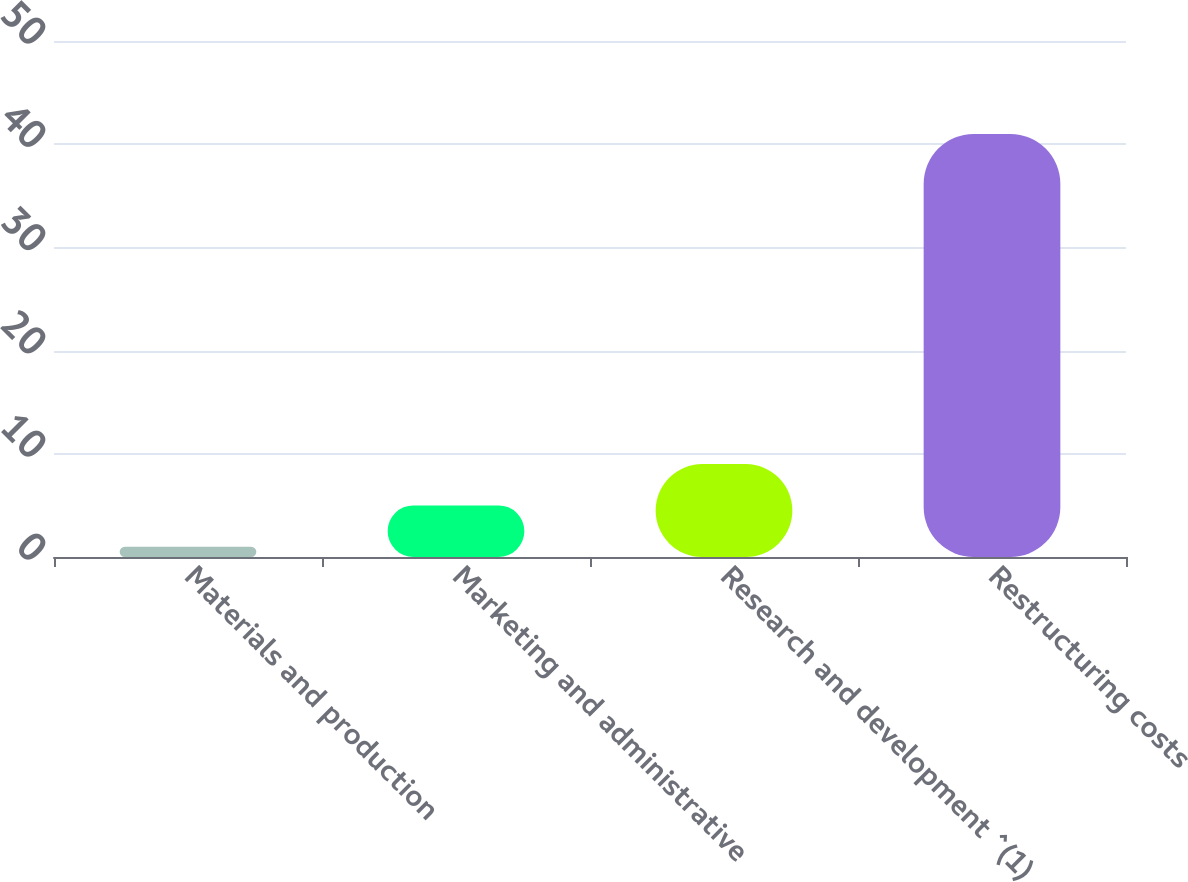Convert chart. <chart><loc_0><loc_0><loc_500><loc_500><bar_chart><fcel>Materials and production<fcel>Marketing and administrative<fcel>Research and development ^(1)<fcel>Restructuring costs<nl><fcel>1<fcel>5<fcel>9<fcel>41<nl></chart> 